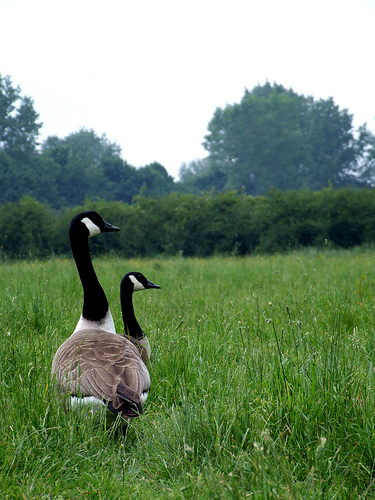<image>
Is there a goose in front of the tree? No. The goose is not in front of the tree. The spatial positioning shows a different relationship between these objects. 